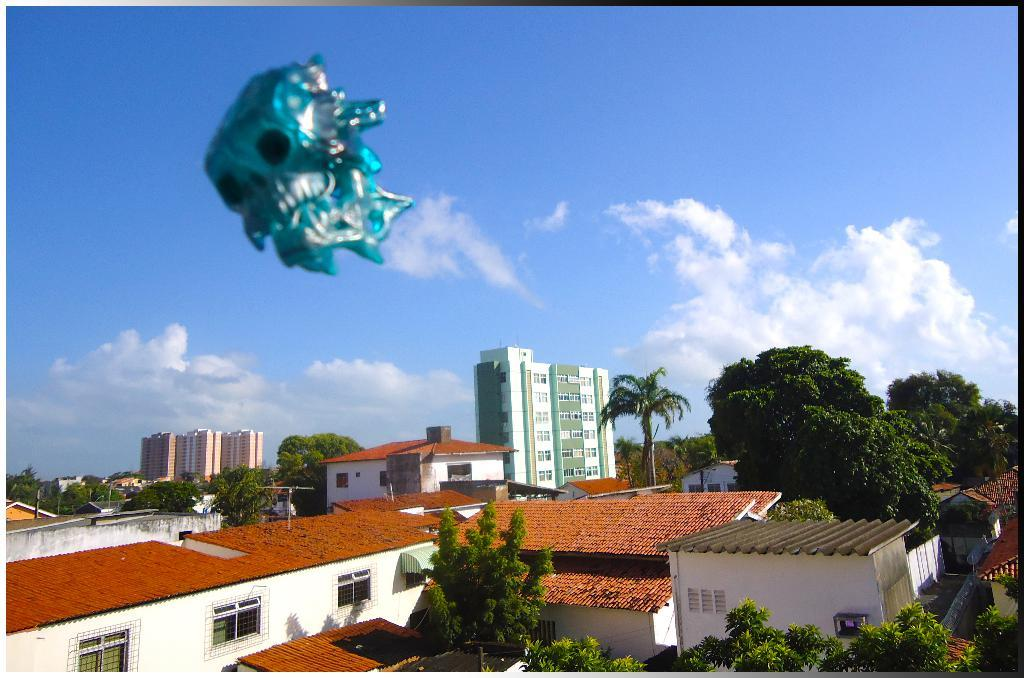What object is located at the top of the image? There is a mask visible at the top of the image. What can be seen in the background of the image? The sky is visible at the top of the image. What type of structures are present at the bottom of the image? There are houses and buildings at the bottom of the image. What type of vegetation is present at the bottom of the image? Trees are present at the bottom of the image. What type of cherry is being used for writing in the image? There is no cherry or writing present in the image. How long does it take for the minute hand to move in the image? There is no clock or time-related object present in the image. 